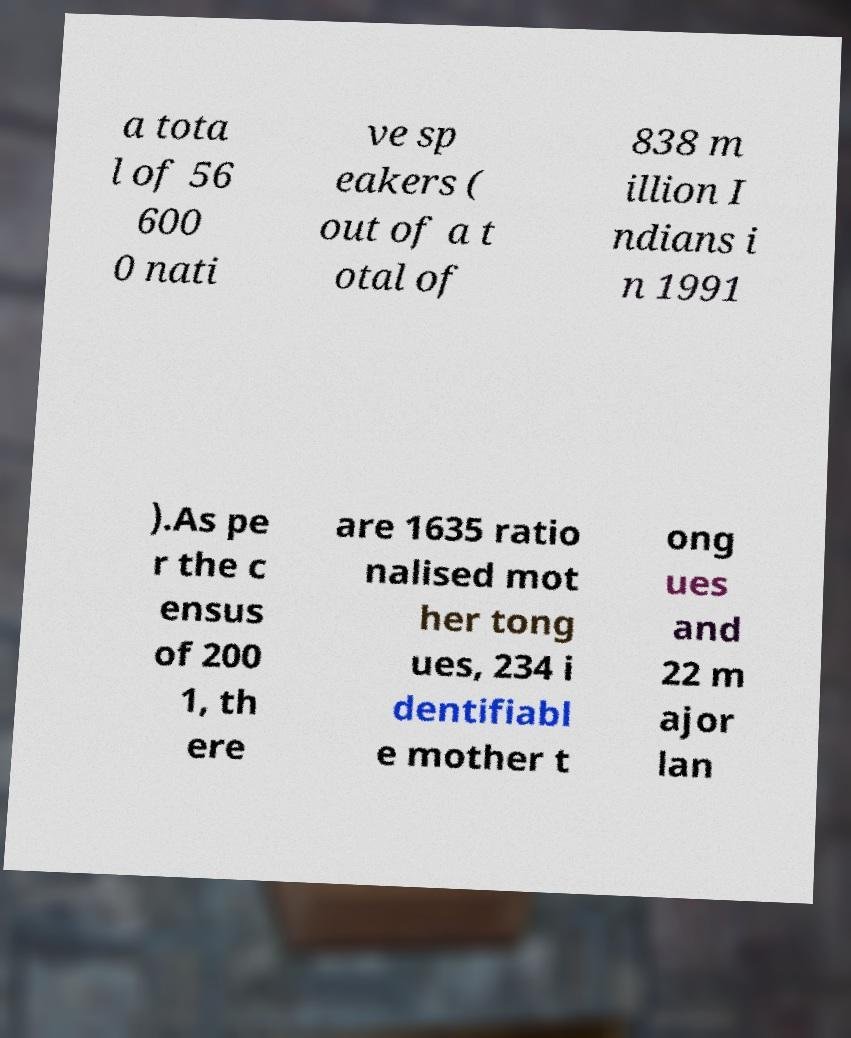For documentation purposes, I need the text within this image transcribed. Could you provide that? a tota l of 56 600 0 nati ve sp eakers ( out of a t otal of 838 m illion I ndians i n 1991 ).As pe r the c ensus of 200 1, th ere are 1635 ratio nalised mot her tong ues, 234 i dentifiabl e mother t ong ues and 22 m ajor lan 